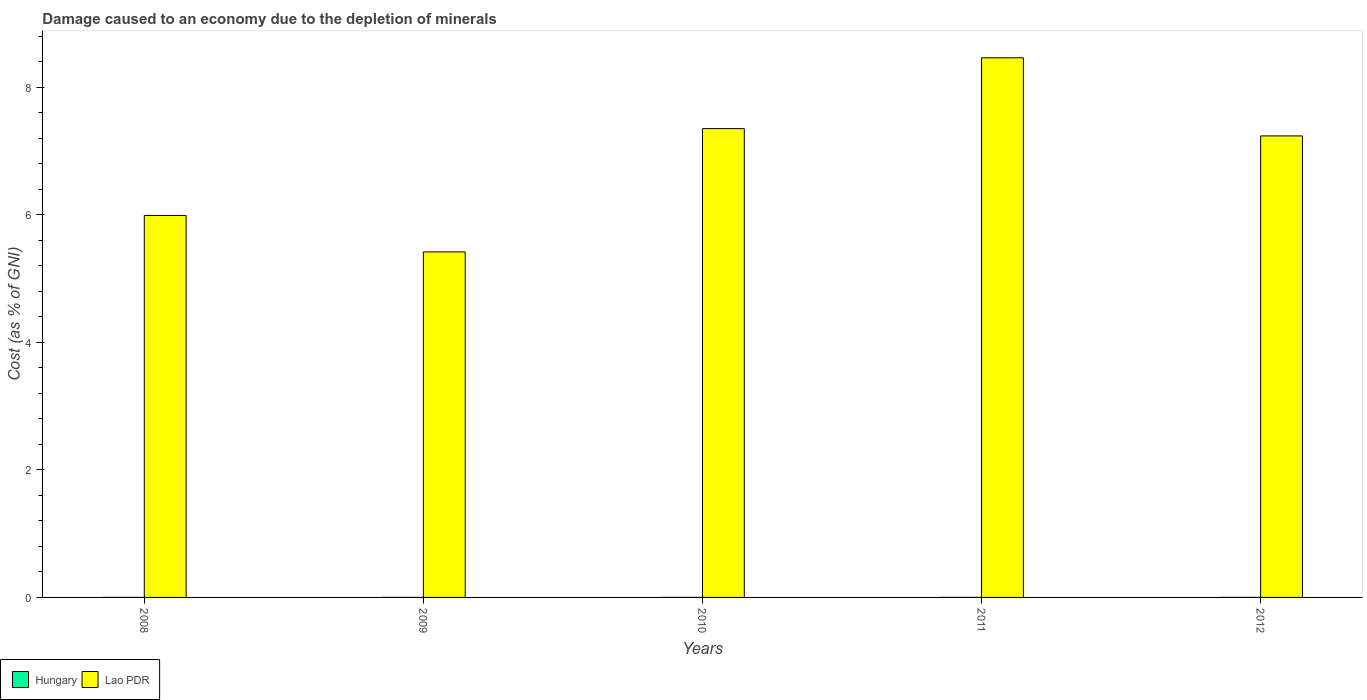How many different coloured bars are there?
Provide a short and direct response. 2. How many groups of bars are there?
Provide a short and direct response. 5. What is the label of the 4th group of bars from the left?
Your response must be concise. 2011. What is the cost of damage caused due to the depletion of minerals in Hungary in 2010?
Offer a very short reply. 0. Across all years, what is the maximum cost of damage caused due to the depletion of minerals in Lao PDR?
Your answer should be very brief. 8.46. Across all years, what is the minimum cost of damage caused due to the depletion of minerals in Hungary?
Offer a very short reply. 0. In which year was the cost of damage caused due to the depletion of minerals in Lao PDR maximum?
Your answer should be compact. 2011. In which year was the cost of damage caused due to the depletion of minerals in Hungary minimum?
Give a very brief answer. 2012. What is the total cost of damage caused due to the depletion of minerals in Lao PDR in the graph?
Your answer should be compact. 34.45. What is the difference between the cost of damage caused due to the depletion of minerals in Hungary in 2009 and that in 2011?
Provide a succinct answer. 0. What is the difference between the cost of damage caused due to the depletion of minerals in Lao PDR in 2011 and the cost of damage caused due to the depletion of minerals in Hungary in 2010?
Ensure brevity in your answer.  8.46. What is the average cost of damage caused due to the depletion of minerals in Lao PDR per year?
Ensure brevity in your answer.  6.89. In the year 2009, what is the difference between the cost of damage caused due to the depletion of minerals in Lao PDR and cost of damage caused due to the depletion of minerals in Hungary?
Your answer should be very brief. 5.42. In how many years, is the cost of damage caused due to the depletion of minerals in Hungary greater than 6.8 %?
Make the answer very short. 0. What is the ratio of the cost of damage caused due to the depletion of minerals in Hungary in 2009 to that in 2011?
Your answer should be compact. 1.22. What is the difference between the highest and the second highest cost of damage caused due to the depletion of minerals in Lao PDR?
Provide a succinct answer. 1.11. What is the difference between the highest and the lowest cost of damage caused due to the depletion of minerals in Lao PDR?
Your response must be concise. 3.04. What does the 1st bar from the left in 2008 represents?
Offer a terse response. Hungary. What does the 2nd bar from the right in 2008 represents?
Your answer should be compact. Hungary. Are all the bars in the graph horizontal?
Offer a terse response. No. How many years are there in the graph?
Your answer should be very brief. 5. Does the graph contain any zero values?
Ensure brevity in your answer.  No. Does the graph contain grids?
Offer a very short reply. No. Where does the legend appear in the graph?
Provide a short and direct response. Bottom left. How many legend labels are there?
Keep it short and to the point. 2. How are the legend labels stacked?
Ensure brevity in your answer.  Horizontal. What is the title of the graph?
Provide a succinct answer. Damage caused to an economy due to the depletion of minerals. What is the label or title of the X-axis?
Offer a terse response. Years. What is the label or title of the Y-axis?
Provide a succinct answer. Cost (as % of GNI). What is the Cost (as % of GNI) in Hungary in 2008?
Keep it short and to the point. 0. What is the Cost (as % of GNI) in Lao PDR in 2008?
Provide a succinct answer. 5.99. What is the Cost (as % of GNI) in Hungary in 2009?
Ensure brevity in your answer.  0. What is the Cost (as % of GNI) in Lao PDR in 2009?
Your answer should be very brief. 5.42. What is the Cost (as % of GNI) in Hungary in 2010?
Make the answer very short. 0. What is the Cost (as % of GNI) of Lao PDR in 2010?
Provide a succinct answer. 7.35. What is the Cost (as % of GNI) of Hungary in 2011?
Ensure brevity in your answer.  0. What is the Cost (as % of GNI) of Lao PDR in 2011?
Your response must be concise. 8.46. What is the Cost (as % of GNI) of Hungary in 2012?
Offer a terse response. 0. What is the Cost (as % of GNI) of Lao PDR in 2012?
Your answer should be compact. 7.24. Across all years, what is the maximum Cost (as % of GNI) in Hungary?
Provide a succinct answer. 0. Across all years, what is the maximum Cost (as % of GNI) of Lao PDR?
Your answer should be very brief. 8.46. Across all years, what is the minimum Cost (as % of GNI) in Hungary?
Your response must be concise. 0. Across all years, what is the minimum Cost (as % of GNI) of Lao PDR?
Make the answer very short. 5.42. What is the total Cost (as % of GNI) in Hungary in the graph?
Provide a succinct answer. 0. What is the total Cost (as % of GNI) in Lao PDR in the graph?
Offer a very short reply. 34.45. What is the difference between the Cost (as % of GNI) of Hungary in 2008 and that in 2009?
Keep it short and to the point. -0. What is the difference between the Cost (as % of GNI) of Lao PDR in 2008 and that in 2009?
Make the answer very short. 0.57. What is the difference between the Cost (as % of GNI) of Hungary in 2008 and that in 2010?
Provide a succinct answer. -0. What is the difference between the Cost (as % of GNI) in Lao PDR in 2008 and that in 2010?
Keep it short and to the point. -1.36. What is the difference between the Cost (as % of GNI) of Hungary in 2008 and that in 2011?
Your answer should be very brief. -0. What is the difference between the Cost (as % of GNI) in Lao PDR in 2008 and that in 2011?
Your response must be concise. -2.47. What is the difference between the Cost (as % of GNI) of Hungary in 2008 and that in 2012?
Provide a succinct answer. 0. What is the difference between the Cost (as % of GNI) of Lao PDR in 2008 and that in 2012?
Give a very brief answer. -1.25. What is the difference between the Cost (as % of GNI) of Hungary in 2009 and that in 2010?
Your answer should be very brief. 0. What is the difference between the Cost (as % of GNI) of Lao PDR in 2009 and that in 2010?
Your answer should be compact. -1.93. What is the difference between the Cost (as % of GNI) of Lao PDR in 2009 and that in 2011?
Your answer should be compact. -3.04. What is the difference between the Cost (as % of GNI) of Lao PDR in 2009 and that in 2012?
Give a very brief answer. -1.82. What is the difference between the Cost (as % of GNI) in Hungary in 2010 and that in 2011?
Offer a very short reply. -0. What is the difference between the Cost (as % of GNI) in Lao PDR in 2010 and that in 2011?
Make the answer very short. -1.11. What is the difference between the Cost (as % of GNI) in Hungary in 2010 and that in 2012?
Offer a terse response. 0. What is the difference between the Cost (as % of GNI) of Lao PDR in 2010 and that in 2012?
Your answer should be very brief. 0.11. What is the difference between the Cost (as % of GNI) in Lao PDR in 2011 and that in 2012?
Give a very brief answer. 1.22. What is the difference between the Cost (as % of GNI) of Hungary in 2008 and the Cost (as % of GNI) of Lao PDR in 2009?
Keep it short and to the point. -5.42. What is the difference between the Cost (as % of GNI) of Hungary in 2008 and the Cost (as % of GNI) of Lao PDR in 2010?
Your answer should be compact. -7.35. What is the difference between the Cost (as % of GNI) of Hungary in 2008 and the Cost (as % of GNI) of Lao PDR in 2011?
Your answer should be compact. -8.46. What is the difference between the Cost (as % of GNI) in Hungary in 2008 and the Cost (as % of GNI) in Lao PDR in 2012?
Your answer should be very brief. -7.24. What is the difference between the Cost (as % of GNI) in Hungary in 2009 and the Cost (as % of GNI) in Lao PDR in 2010?
Give a very brief answer. -7.35. What is the difference between the Cost (as % of GNI) in Hungary in 2009 and the Cost (as % of GNI) in Lao PDR in 2011?
Your response must be concise. -8.46. What is the difference between the Cost (as % of GNI) in Hungary in 2009 and the Cost (as % of GNI) in Lao PDR in 2012?
Ensure brevity in your answer.  -7.24. What is the difference between the Cost (as % of GNI) in Hungary in 2010 and the Cost (as % of GNI) in Lao PDR in 2011?
Ensure brevity in your answer.  -8.46. What is the difference between the Cost (as % of GNI) in Hungary in 2010 and the Cost (as % of GNI) in Lao PDR in 2012?
Offer a terse response. -7.24. What is the difference between the Cost (as % of GNI) in Hungary in 2011 and the Cost (as % of GNI) in Lao PDR in 2012?
Provide a succinct answer. -7.24. What is the average Cost (as % of GNI) of Hungary per year?
Keep it short and to the point. 0. What is the average Cost (as % of GNI) of Lao PDR per year?
Give a very brief answer. 6.89. In the year 2008, what is the difference between the Cost (as % of GNI) of Hungary and Cost (as % of GNI) of Lao PDR?
Offer a terse response. -5.99. In the year 2009, what is the difference between the Cost (as % of GNI) in Hungary and Cost (as % of GNI) in Lao PDR?
Offer a very short reply. -5.42. In the year 2010, what is the difference between the Cost (as % of GNI) of Hungary and Cost (as % of GNI) of Lao PDR?
Keep it short and to the point. -7.35. In the year 2011, what is the difference between the Cost (as % of GNI) in Hungary and Cost (as % of GNI) in Lao PDR?
Your answer should be very brief. -8.46. In the year 2012, what is the difference between the Cost (as % of GNI) in Hungary and Cost (as % of GNI) in Lao PDR?
Ensure brevity in your answer.  -7.24. What is the ratio of the Cost (as % of GNI) of Hungary in 2008 to that in 2009?
Make the answer very short. 0.63. What is the ratio of the Cost (as % of GNI) of Lao PDR in 2008 to that in 2009?
Provide a short and direct response. 1.11. What is the ratio of the Cost (as % of GNI) of Hungary in 2008 to that in 2010?
Ensure brevity in your answer.  0.8. What is the ratio of the Cost (as % of GNI) in Lao PDR in 2008 to that in 2010?
Make the answer very short. 0.81. What is the ratio of the Cost (as % of GNI) of Hungary in 2008 to that in 2011?
Make the answer very short. 0.77. What is the ratio of the Cost (as % of GNI) of Lao PDR in 2008 to that in 2011?
Your response must be concise. 0.71. What is the ratio of the Cost (as % of GNI) of Hungary in 2008 to that in 2012?
Your answer should be compact. 1.2. What is the ratio of the Cost (as % of GNI) of Lao PDR in 2008 to that in 2012?
Keep it short and to the point. 0.83. What is the ratio of the Cost (as % of GNI) of Hungary in 2009 to that in 2010?
Ensure brevity in your answer.  1.28. What is the ratio of the Cost (as % of GNI) of Lao PDR in 2009 to that in 2010?
Your response must be concise. 0.74. What is the ratio of the Cost (as % of GNI) in Hungary in 2009 to that in 2011?
Offer a terse response. 1.22. What is the ratio of the Cost (as % of GNI) in Lao PDR in 2009 to that in 2011?
Provide a succinct answer. 0.64. What is the ratio of the Cost (as % of GNI) in Hungary in 2009 to that in 2012?
Provide a short and direct response. 1.91. What is the ratio of the Cost (as % of GNI) in Lao PDR in 2009 to that in 2012?
Your answer should be very brief. 0.75. What is the ratio of the Cost (as % of GNI) in Hungary in 2010 to that in 2011?
Offer a terse response. 0.96. What is the ratio of the Cost (as % of GNI) of Lao PDR in 2010 to that in 2011?
Offer a terse response. 0.87. What is the ratio of the Cost (as % of GNI) of Hungary in 2010 to that in 2012?
Your answer should be compact. 1.5. What is the ratio of the Cost (as % of GNI) in Lao PDR in 2010 to that in 2012?
Provide a short and direct response. 1.02. What is the ratio of the Cost (as % of GNI) of Hungary in 2011 to that in 2012?
Give a very brief answer. 1.57. What is the ratio of the Cost (as % of GNI) in Lao PDR in 2011 to that in 2012?
Provide a short and direct response. 1.17. What is the difference between the highest and the second highest Cost (as % of GNI) of Lao PDR?
Offer a terse response. 1.11. What is the difference between the highest and the lowest Cost (as % of GNI) in Hungary?
Offer a very short reply. 0. What is the difference between the highest and the lowest Cost (as % of GNI) in Lao PDR?
Make the answer very short. 3.04. 